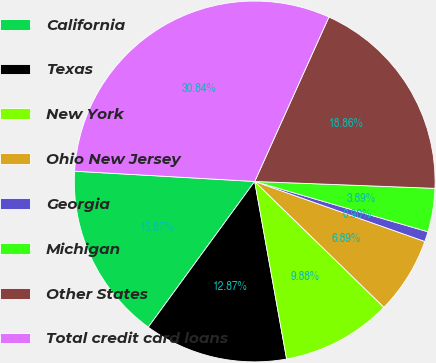Convert chart. <chart><loc_0><loc_0><loc_500><loc_500><pie_chart><fcel>California<fcel>Texas<fcel>New York<fcel>Ohio New Jersey<fcel>Georgia<fcel>Michigan<fcel>Other States<fcel>Total credit card loans<nl><fcel>15.87%<fcel>12.87%<fcel>9.88%<fcel>6.89%<fcel>0.9%<fcel>3.89%<fcel>18.86%<fcel>30.84%<nl></chart> 